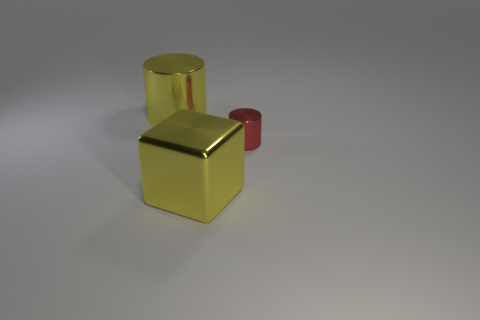Add 1 big metal cubes. How many objects exist? 4 Subtract all cylinders. How many objects are left? 1 Subtract 0 cyan spheres. How many objects are left? 3 Subtract all small brown matte blocks. Subtract all cylinders. How many objects are left? 1 Add 3 red metal objects. How many red metal objects are left? 4 Add 3 objects. How many objects exist? 6 